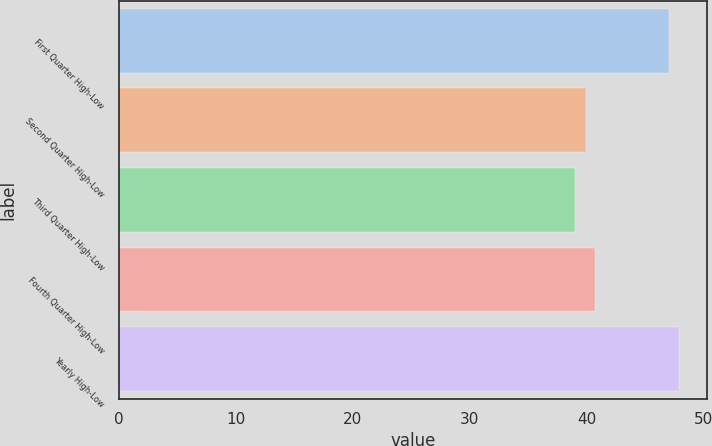Convert chart to OTSL. <chart><loc_0><loc_0><loc_500><loc_500><bar_chart><fcel>First Quarter High-Low<fcel>Second Quarter High-Low<fcel>Third Quarter High-Low<fcel>Fourth Quarter High-Low<fcel>Yearly High-Low<nl><fcel>47.09<fcel>39.96<fcel>39.06<fcel>40.76<fcel>47.89<nl></chart> 